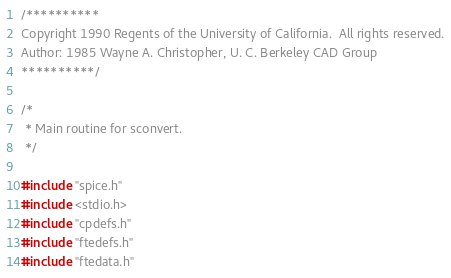Convert code to text. <code><loc_0><loc_0><loc_500><loc_500><_C_>/**********
Copyright 1990 Regents of the University of California.  All rights reserved.
Author: 1985 Wayne A. Christopher, U. C. Berkeley CAD Group
**********/

/*
 * Main routine for sconvert.
 */

#include "spice.h"
#include <stdio.h>
#include "cpdefs.h"
#include "ftedefs.h"
#include "ftedata.h"</code> 